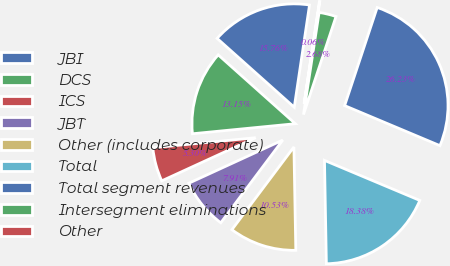Convert chart to OTSL. <chart><loc_0><loc_0><loc_500><loc_500><pie_chart><fcel>JBI<fcel>DCS<fcel>ICS<fcel>JBT<fcel>Other (includes corporate)<fcel>Total<fcel>Total segment revenues<fcel>Intersegment eliminations<fcel>Other<nl><fcel>15.76%<fcel>13.15%<fcel>5.3%<fcel>7.91%<fcel>10.53%<fcel>18.38%<fcel>26.23%<fcel>2.68%<fcel>0.06%<nl></chart> 